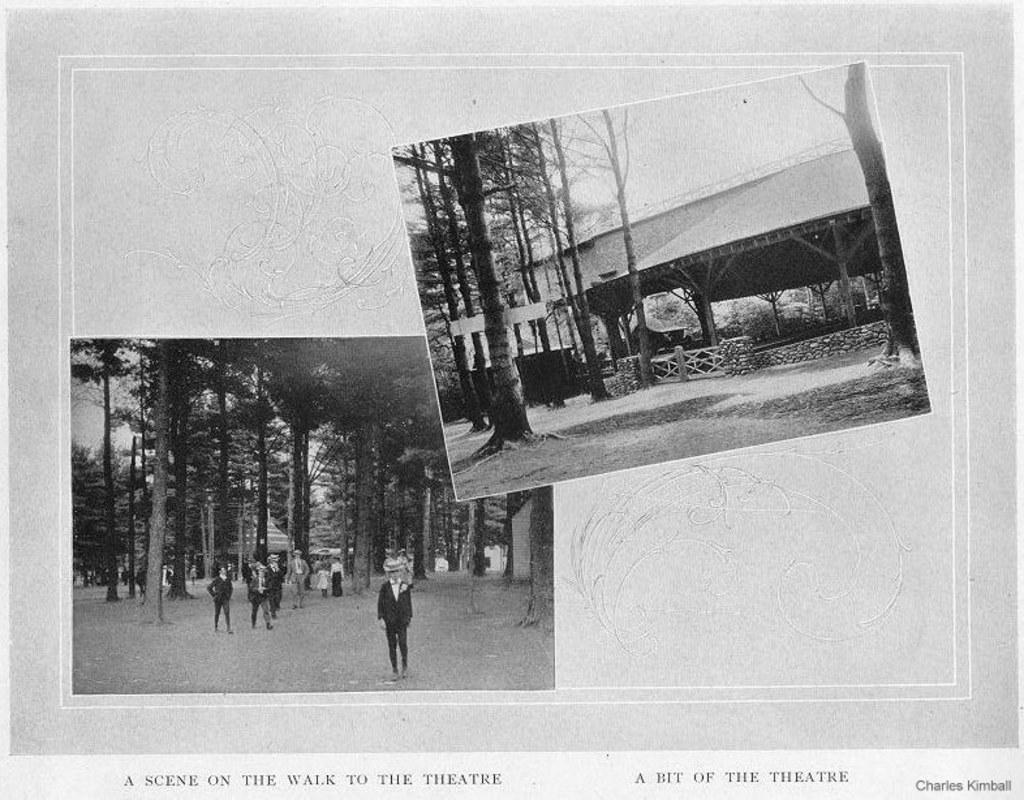Please provide a concise description of this image. In this image I can see two photo frames in which a crowd, trees, shed, fence and the sky is there. This image is taken may be during a day. 